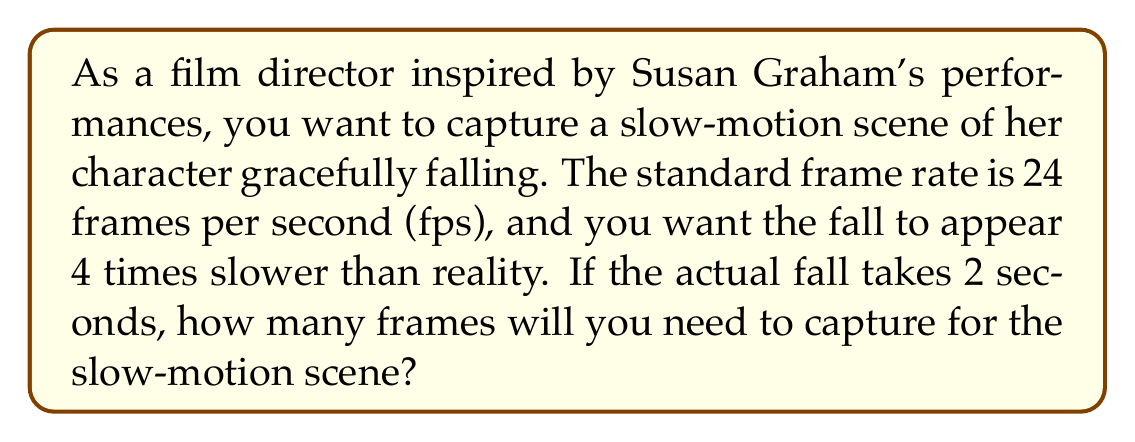Could you help me with this problem? Let's approach this step-by-step:

1) First, we need to determine the frame rate required for the slow-motion effect:
   - Standard frame rate: 24 fps
   - Desired slow-motion effect: 4 times slower
   - Required frame rate: $24 \times 4 = 96$ fps

2) Now, we can set up a linear equation to find the number of frames:
   Let $x$ be the number of frames we need to capture.

   $$\frac{x \text{ frames}}{2 \text{ seconds}} = 96 \text{ fps}$$

3) Solve for $x$:
   $$x = 96 \text{ fps} \times 2 \text{ seconds} = 192 \text{ frames}$$

4) Therefore, you need to capture 192 frames to create the desired slow-motion effect for Susan Graham's 2-second fall.
Answer: 192 frames 